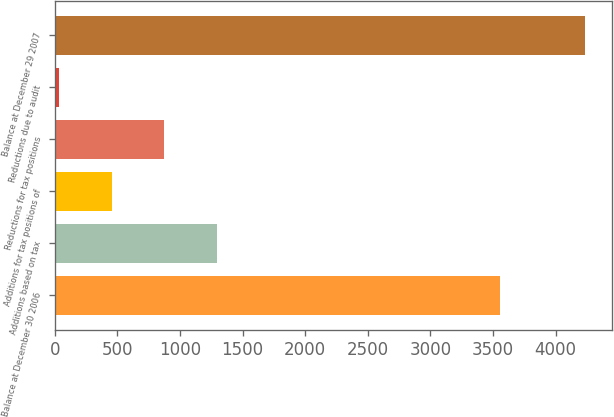Convert chart. <chart><loc_0><loc_0><loc_500><loc_500><bar_chart><fcel>Balance at December 30 2006<fcel>Additions based on tax<fcel>Additions for tax positions of<fcel>Reductions for tax positions<fcel>Reductions due to audit<fcel>Balance at December 29 2007<nl><fcel>3558<fcel>1295.3<fcel>455.1<fcel>875.2<fcel>35<fcel>4236<nl></chart> 